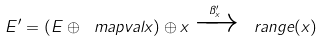Convert formula to latex. <formula><loc_0><loc_0><loc_500><loc_500>E ^ { \prime } = ( E \oplus \ m a p v a l { x } ) \oplus x \xrightarrow { \pi _ { x } ^ { \prime } } \ r a n g e ( x )</formula> 